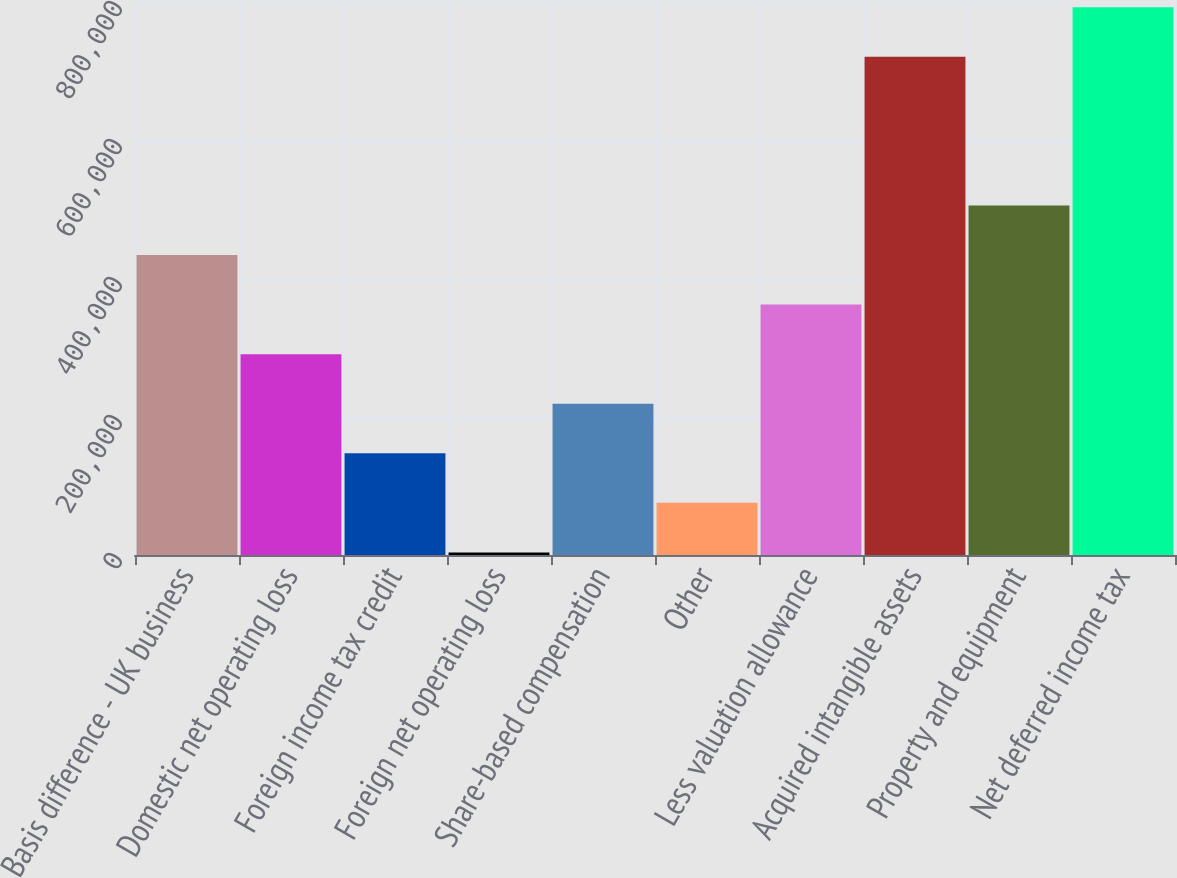<chart> <loc_0><loc_0><loc_500><loc_500><bar_chart><fcel>Basis difference - UK business<fcel>Domestic net operating loss<fcel>Foreign income tax credit<fcel>Foreign net operating loss<fcel>Share-based compensation<fcel>Other<fcel>Less valuation allowance<fcel>Acquired intangible assets<fcel>Property and equipment<fcel>Net deferred income tax<nl><fcel>434774<fcel>291090<fcel>147405<fcel>3721<fcel>219248<fcel>75563.2<fcel>362932<fcel>721928<fcel>506616<fcel>793770<nl></chart> 